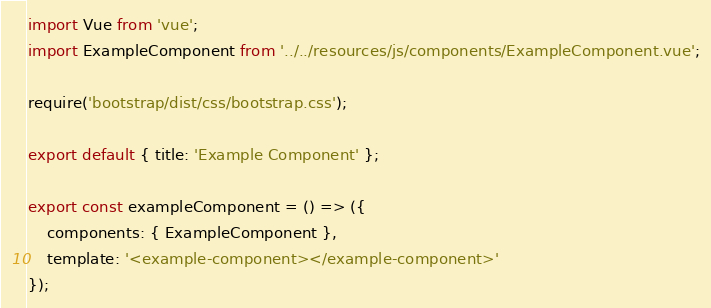<code> <loc_0><loc_0><loc_500><loc_500><_JavaScript_>import Vue from 'vue';
import ExampleComponent from '../../resources/js/components/ExampleComponent.vue';

require('bootstrap/dist/css/bootstrap.css');

export default { title: 'Example Component' };

export const exampleComponent = () => ({
    components: { ExampleComponent },
    template: '<example-component></example-component>'
});</code> 